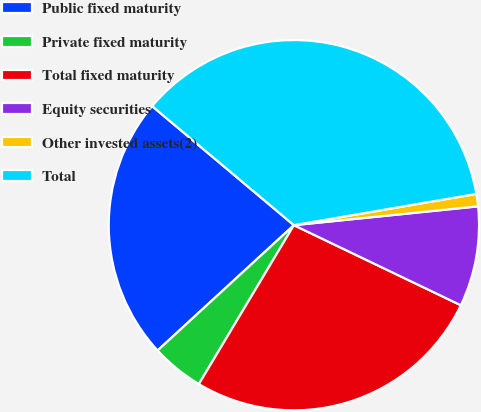Convert chart. <chart><loc_0><loc_0><loc_500><loc_500><pie_chart><fcel>Public fixed maturity<fcel>Private fixed maturity<fcel>Total fixed maturity<fcel>Equity securities<fcel>Other invested assets(2)<fcel>Total<nl><fcel>22.95%<fcel>4.59%<fcel>26.46%<fcel>8.74%<fcel>1.08%<fcel>36.18%<nl></chart> 